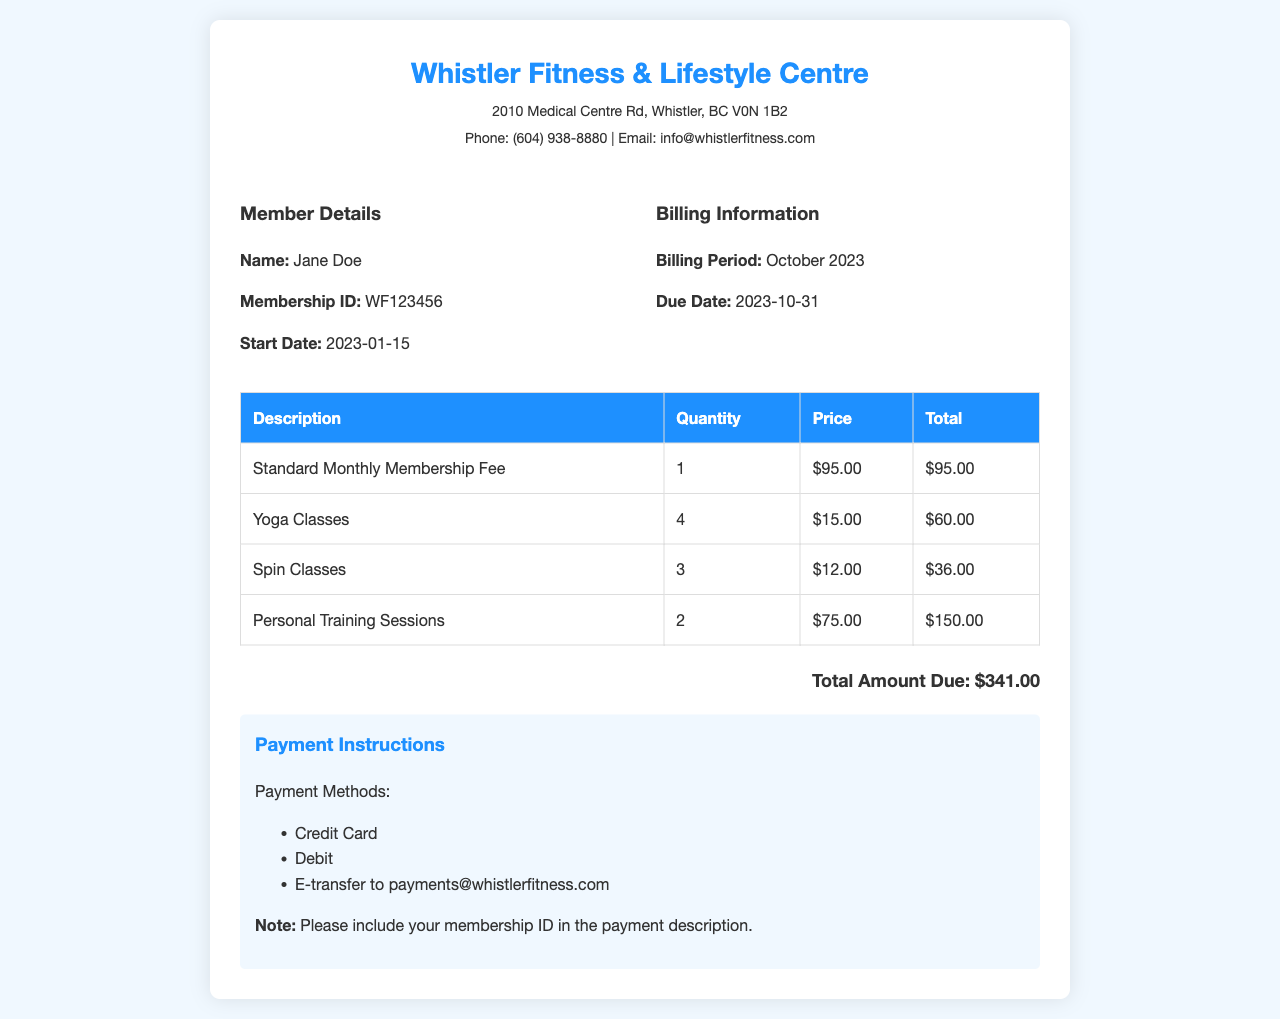what is the membership ID? The membership ID for the member is listed in the document under Member Details.
Answer: WF123456 what is the total amount due? The total amount due is stated at the bottom of the invoice in the total section.
Answer: $341.00 how many yoga classes were attended? The number of yoga classes attended can be found in the description section of the invoice table.
Answer: 4 what is the due date for the invoice? The due date is specified in the Billing Information section of the document.
Answer: 2023-10-31 what is the price of a personal training session? The price per personal training session is indicated in the invoice table alongside the description.
Answer: $75.00 what is the billing period? The billing period is mentioned in the Billing Information section of the document.
Answer: October 2023 how many spin classes were attended? The quantity of spin classes attended is shown in the invoice table.
Answer: 3 what payment methods are accepted? The accepted payment methods are listed in the Payment Instructions section of the invoice.
Answer: Credit Card, Debit, E-transfer what is the start date of the membership? The start date is found in the Member Details section of the document.
Answer: 2023-01-15 